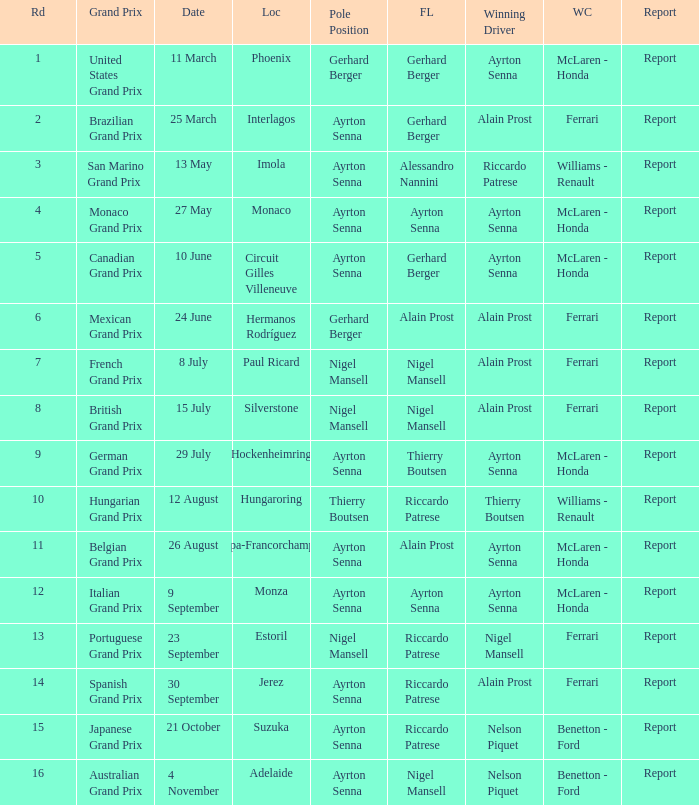What was the constructor when riccardo patrese was the winning driver? Williams - Renault. 